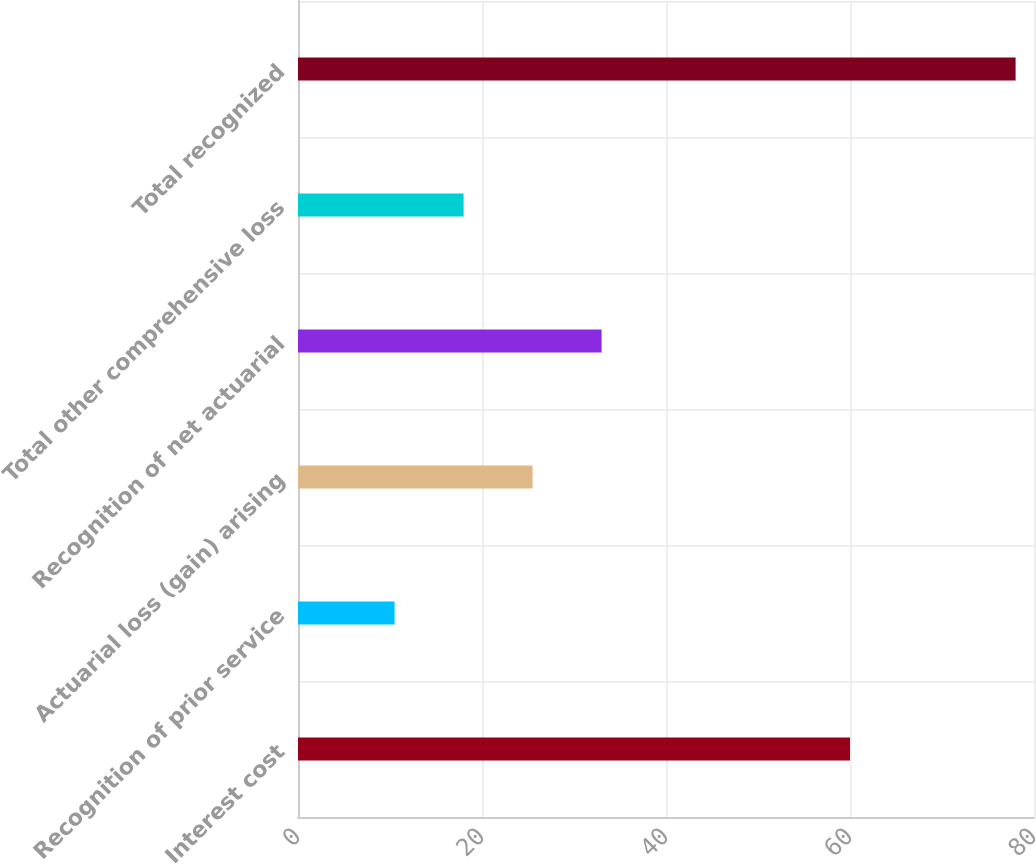<chart> <loc_0><loc_0><loc_500><loc_500><bar_chart><fcel>Interest cost<fcel>Recognition of prior service<fcel>Actuarial loss (gain) arising<fcel>Recognition of net actuarial<fcel>Total other comprehensive loss<fcel>Total recognized<nl><fcel>60<fcel>10.5<fcel>25.5<fcel>33<fcel>18<fcel>78<nl></chart> 